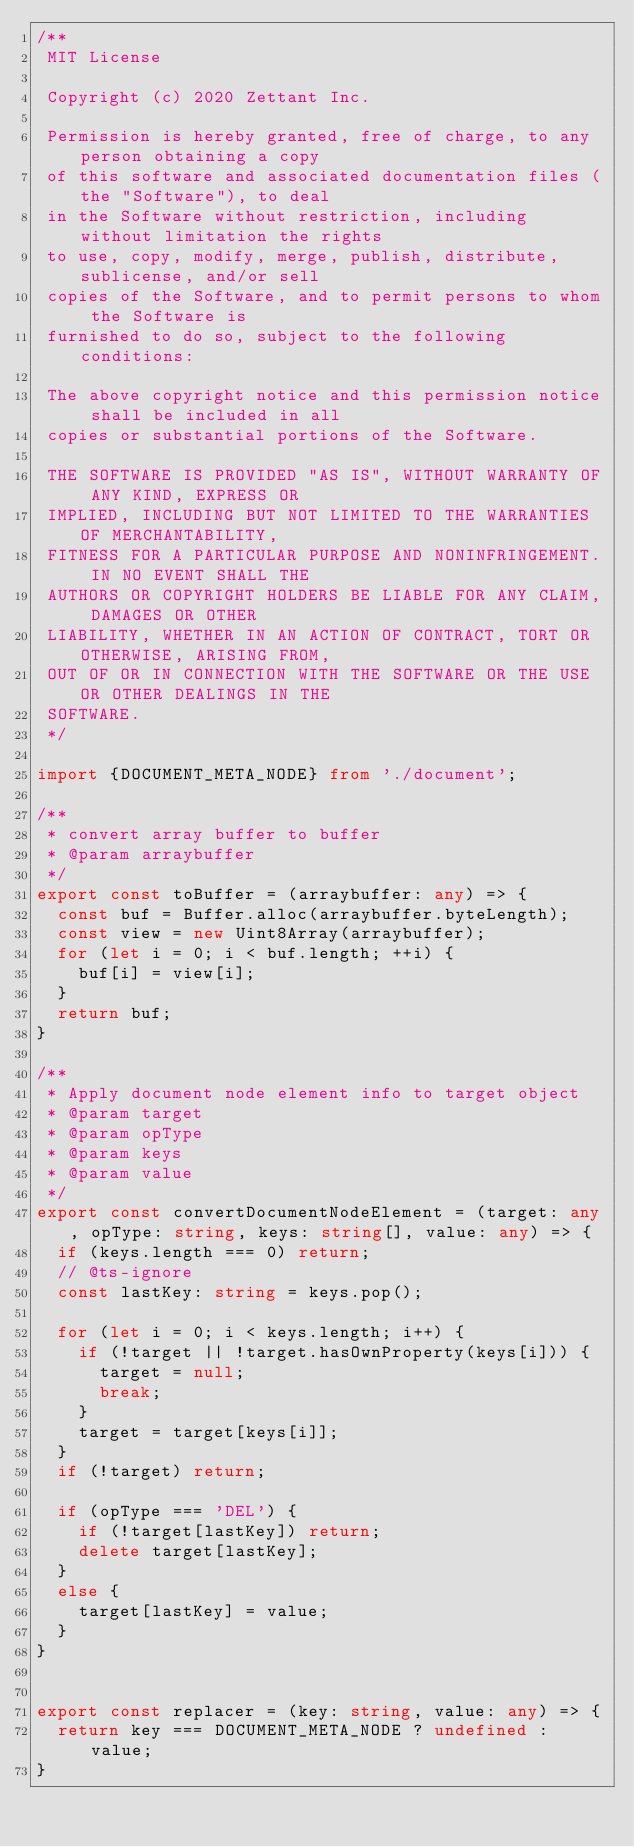Convert code to text. <code><loc_0><loc_0><loc_500><loc_500><_TypeScript_>/**
 MIT License

 Copyright (c) 2020 Zettant Inc.

 Permission is hereby granted, free of charge, to any person obtaining a copy
 of this software and associated documentation files (the "Software"), to deal
 in the Software without restriction, including without limitation the rights
 to use, copy, modify, merge, publish, distribute, sublicense, and/or sell
 copies of the Software, and to permit persons to whom the Software is
 furnished to do so, subject to the following conditions:

 The above copyright notice and this permission notice shall be included in all
 copies or substantial portions of the Software.

 THE SOFTWARE IS PROVIDED "AS IS", WITHOUT WARRANTY OF ANY KIND, EXPRESS OR
 IMPLIED, INCLUDING BUT NOT LIMITED TO THE WARRANTIES OF MERCHANTABILITY,
 FITNESS FOR A PARTICULAR PURPOSE AND NONINFRINGEMENT. IN NO EVENT SHALL THE
 AUTHORS OR COPYRIGHT HOLDERS BE LIABLE FOR ANY CLAIM, DAMAGES OR OTHER
 LIABILITY, WHETHER IN AN ACTION OF CONTRACT, TORT OR OTHERWISE, ARISING FROM,
 OUT OF OR IN CONNECTION WITH THE SOFTWARE OR THE USE OR OTHER DEALINGS IN THE
 SOFTWARE.
 */

import {DOCUMENT_META_NODE} from './document';

/**
 * convert array buffer to buffer
 * @param arraybuffer
 */
export const toBuffer = (arraybuffer: any) => {
  const buf = Buffer.alloc(arraybuffer.byteLength);
  const view = new Uint8Array(arraybuffer);
  for (let i = 0; i < buf.length; ++i) {
    buf[i] = view[i];
  }
  return buf;
}

/**
 * Apply document node element info to target object
 * @param target
 * @param opType
 * @param keys
 * @param value
 */
export const convertDocumentNodeElement = (target: any, opType: string, keys: string[], value: any) => {
  if (keys.length === 0) return;
  // @ts-ignore
  const lastKey: string = keys.pop();

  for (let i = 0; i < keys.length; i++) {
    if (!target || !target.hasOwnProperty(keys[i])) {
      target = null;
      break;
    }
    target = target[keys[i]];
  }
  if (!target) return;

  if (opType === 'DEL') {
    if (!target[lastKey]) return;
    delete target[lastKey];
  }
  else {
    target[lastKey] = value;
  }
}


export const replacer = (key: string, value: any) => {
  return key === DOCUMENT_META_NODE ? undefined : value;
}
</code> 